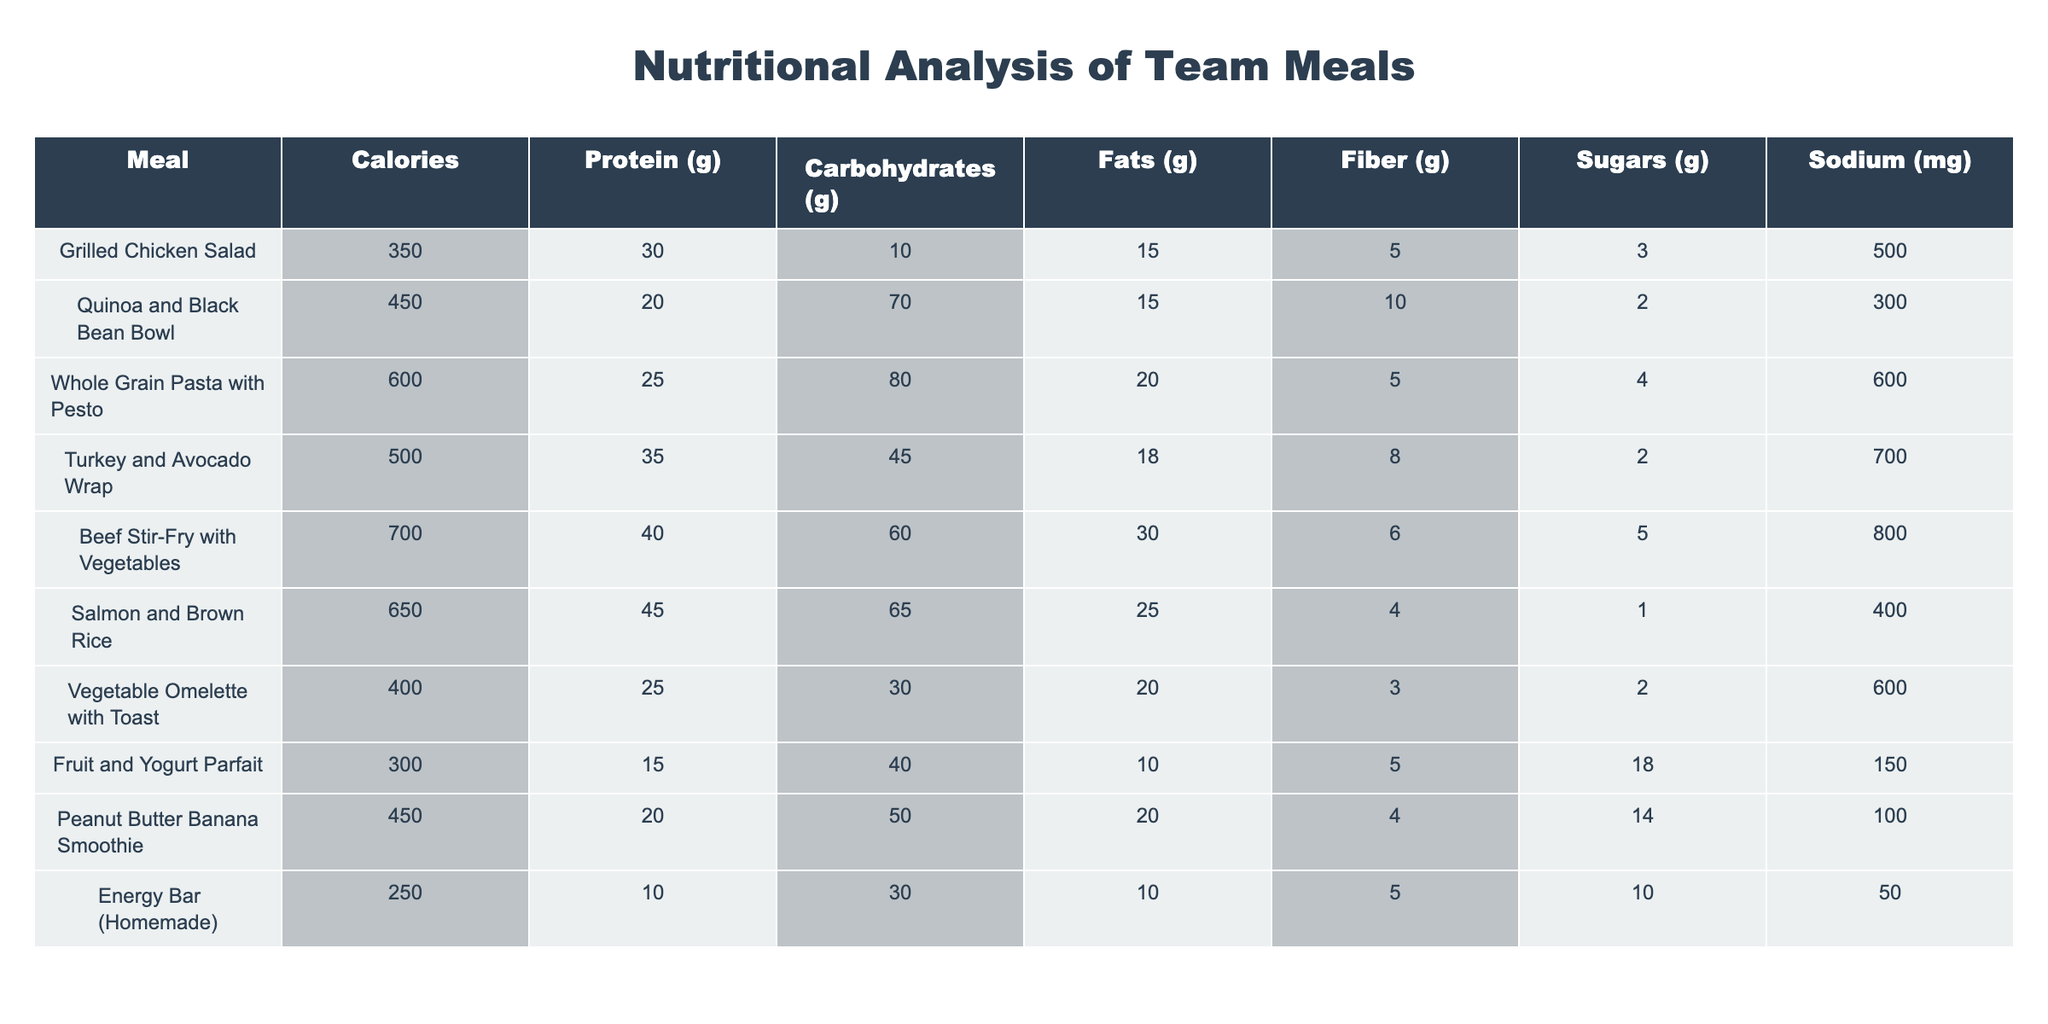What's the calorie content of the Turkey and Avocado Wrap? The calorie content of each meal is listed in the table. For the Turkey and Avocado Wrap, the corresponding value is 500 calories.
Answer: 500 calories Which meal has the highest protein content? By examining the protein column, the Beef Stir-Fry with Vegetables has the highest protein at 40 grams.
Answer: Beef Stir-Fry with Vegetables How many meals contain more than 20 grams of fat? Looking at the fats column, I see that the Whole Grain Pasta with Pesto (20 grams), Beef Stir-Fry with Vegetables (30 grams), and Salmon and Brown Rice (25 grams) exceed 20 grams of fat. Therefore, there are 3 meals.
Answer: 3 meals What is the average carbohydrate content of all meals? To find the average, I first add all carbohydrate values: (10 + 70 + 80 + 45 + 60 + 65 + 30 + 40 + 50 + 30) =  440 grams. Then, since there are 10 meals, I divide 440 by 10 to get an average of 44 grams per meal.
Answer: 44 grams Is there a meal with less than 200 mg of sodium? Looking at the sodium values for each meal, I find that the Energy Bar (Homemade) has only 50 mg of sodium, which is less than 200 mg.
Answer: Yes Which meal has the highest total calories and what is that value? The calories for each meal can be seen directly; the Beef Stir-Fry with Vegetables has the highest calorie count at 700 calories.
Answer: 700 calories What is the total fiber content of the Grilled Chicken Salad and the Vegetable Omelette with Toast combined? The fiber content for Grilled Chicken Salad is 5 grams and for Vegetable Omelette with Toast, it's 3 grams. Adding them gives 5 + 3 = 8 grams of fiber.
Answer: 8 grams Are all meals high in sugars (greater than 10 grams)? By checking the sugars column, I see that the Fruit and Yogurt Parfait has 18 grams of sugar, while the Energy Bar (Homemade) has only 10 grams. Therefore, not all meals are high in sugars.
Answer: No What meal has the lowest calorie content and how many grams of protein does it have? The lowest calorie content is found in the Energy Bar (Homemade) with 250 calories, which has 10 grams of protein.
Answer: Energy Bar (Homemade), 10 grams 